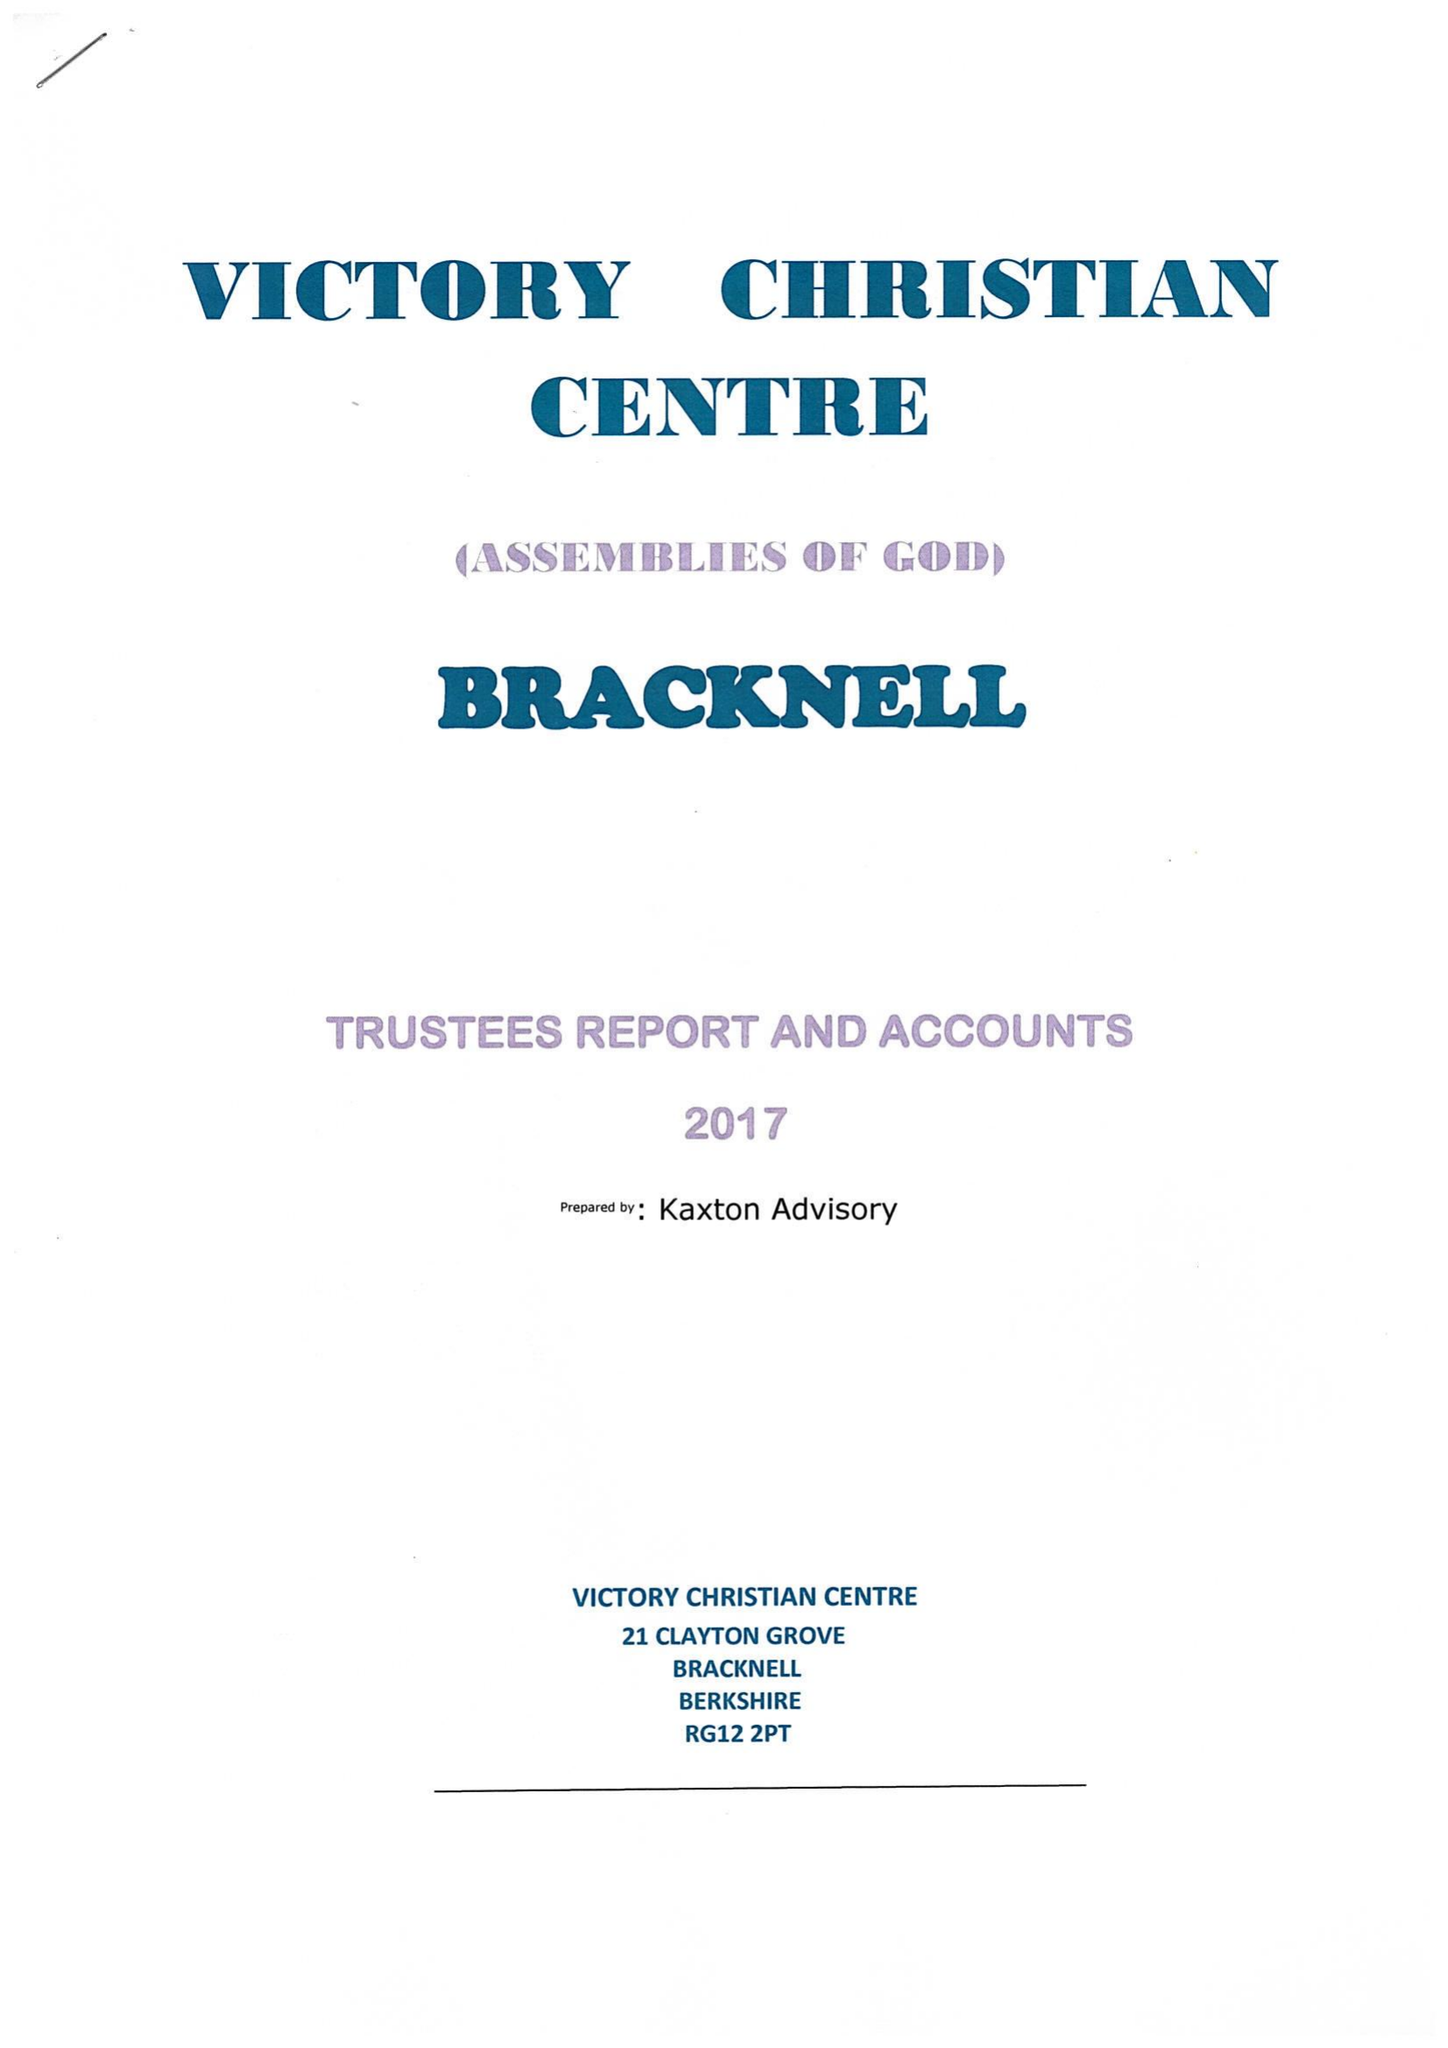What is the value for the address__post_town?
Answer the question using a single word or phrase. BRACKNELL 